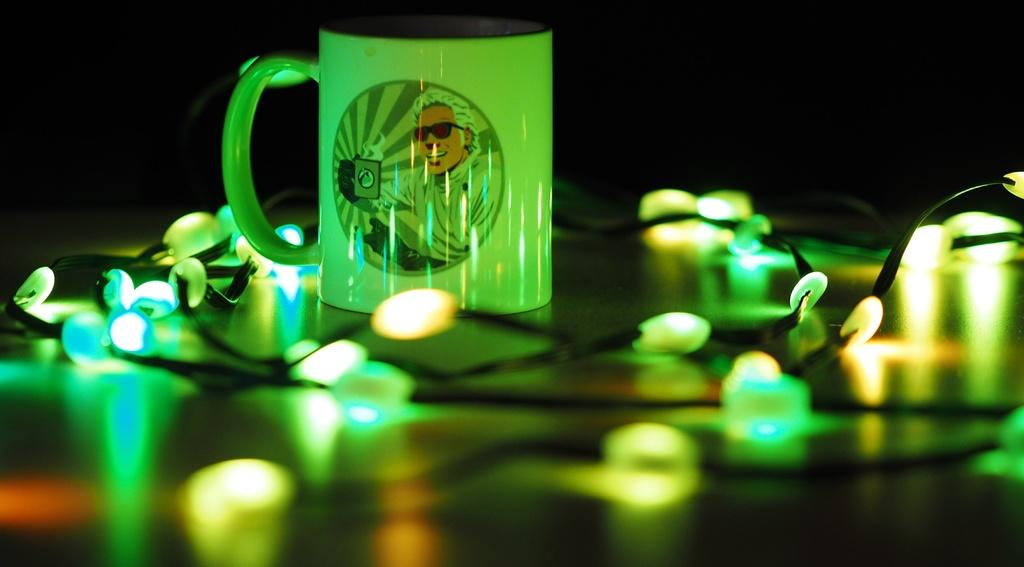What object is visible in the image that can hold liquids? There is a cup in the image that can hold liquids. What can be seen in the image that provides illumination? There are lights in the image that provide illumination. Where are the cup and lights located in the image? The cup and lights are placed on a table in the image. How many ducks are sitting on the table in the image? There are no ducks present in the image; it only features a cup and lights on a table. What time of day is depicted in the image? The time of day cannot be determined from the image, as there is no information about the lighting or shadows to indicate whether it is day or night. 